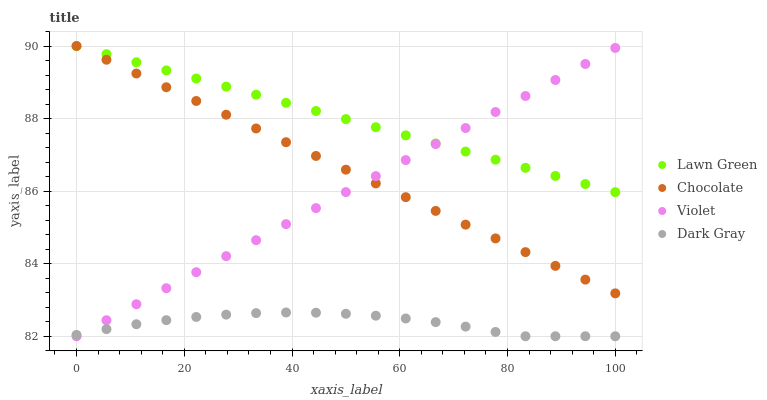Does Dark Gray have the minimum area under the curve?
Answer yes or no. Yes. Does Lawn Green have the maximum area under the curve?
Answer yes or no. Yes. Does Violet have the minimum area under the curve?
Answer yes or no. No. Does Violet have the maximum area under the curve?
Answer yes or no. No. Is Violet the smoothest?
Answer yes or no. Yes. Is Dark Gray the roughest?
Answer yes or no. Yes. Is Lawn Green the smoothest?
Answer yes or no. No. Is Lawn Green the roughest?
Answer yes or no. No. Does Dark Gray have the lowest value?
Answer yes or no. Yes. Does Lawn Green have the lowest value?
Answer yes or no. No. Does Chocolate have the highest value?
Answer yes or no. Yes. Does Violet have the highest value?
Answer yes or no. No. Is Dark Gray less than Chocolate?
Answer yes or no. Yes. Is Lawn Green greater than Dark Gray?
Answer yes or no. Yes. Does Chocolate intersect Violet?
Answer yes or no. Yes. Is Chocolate less than Violet?
Answer yes or no. No. Is Chocolate greater than Violet?
Answer yes or no. No. Does Dark Gray intersect Chocolate?
Answer yes or no. No. 